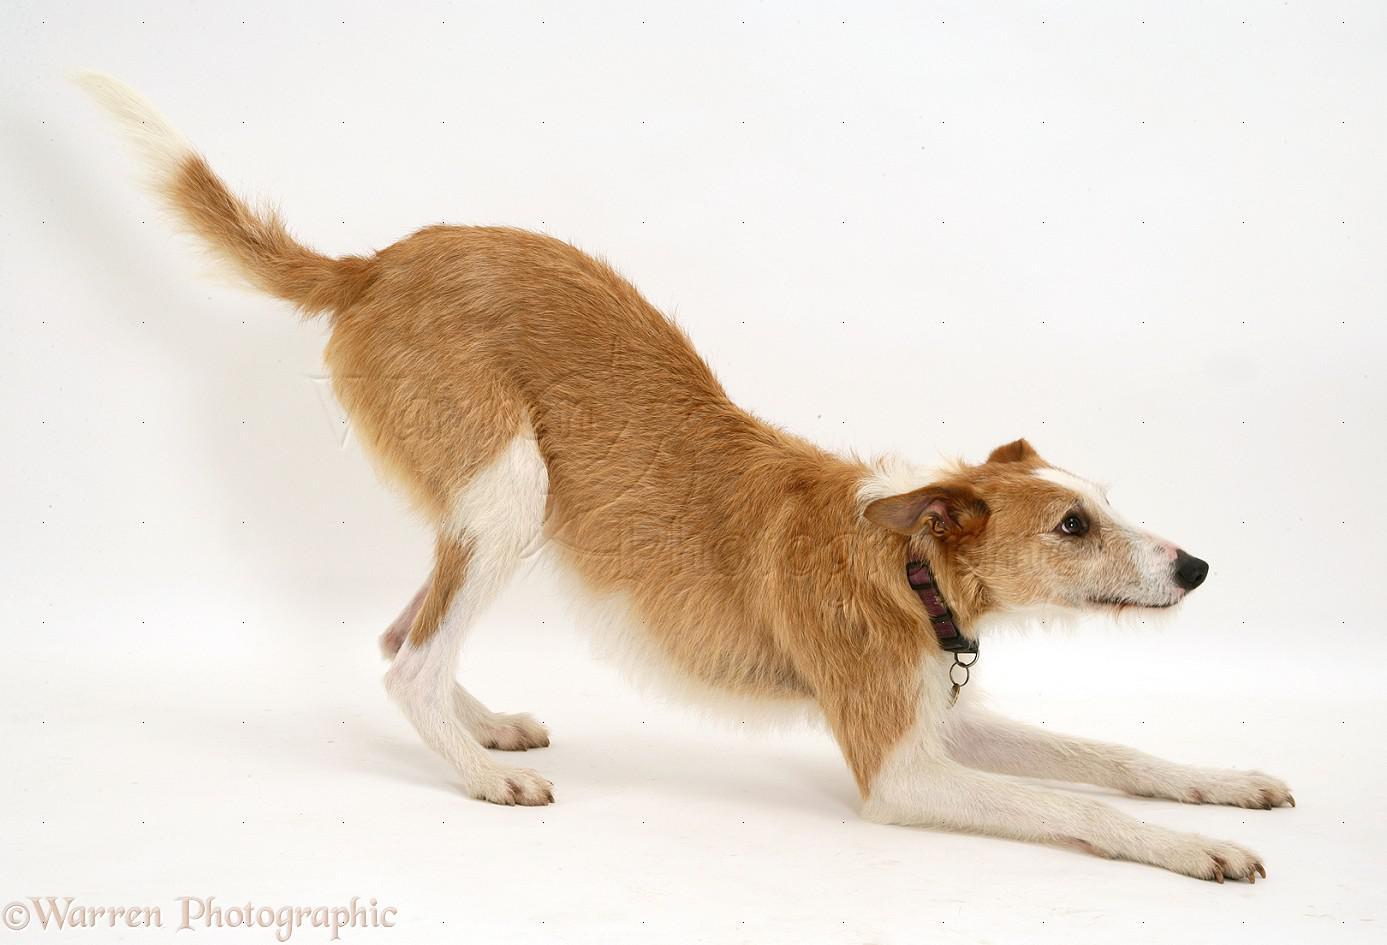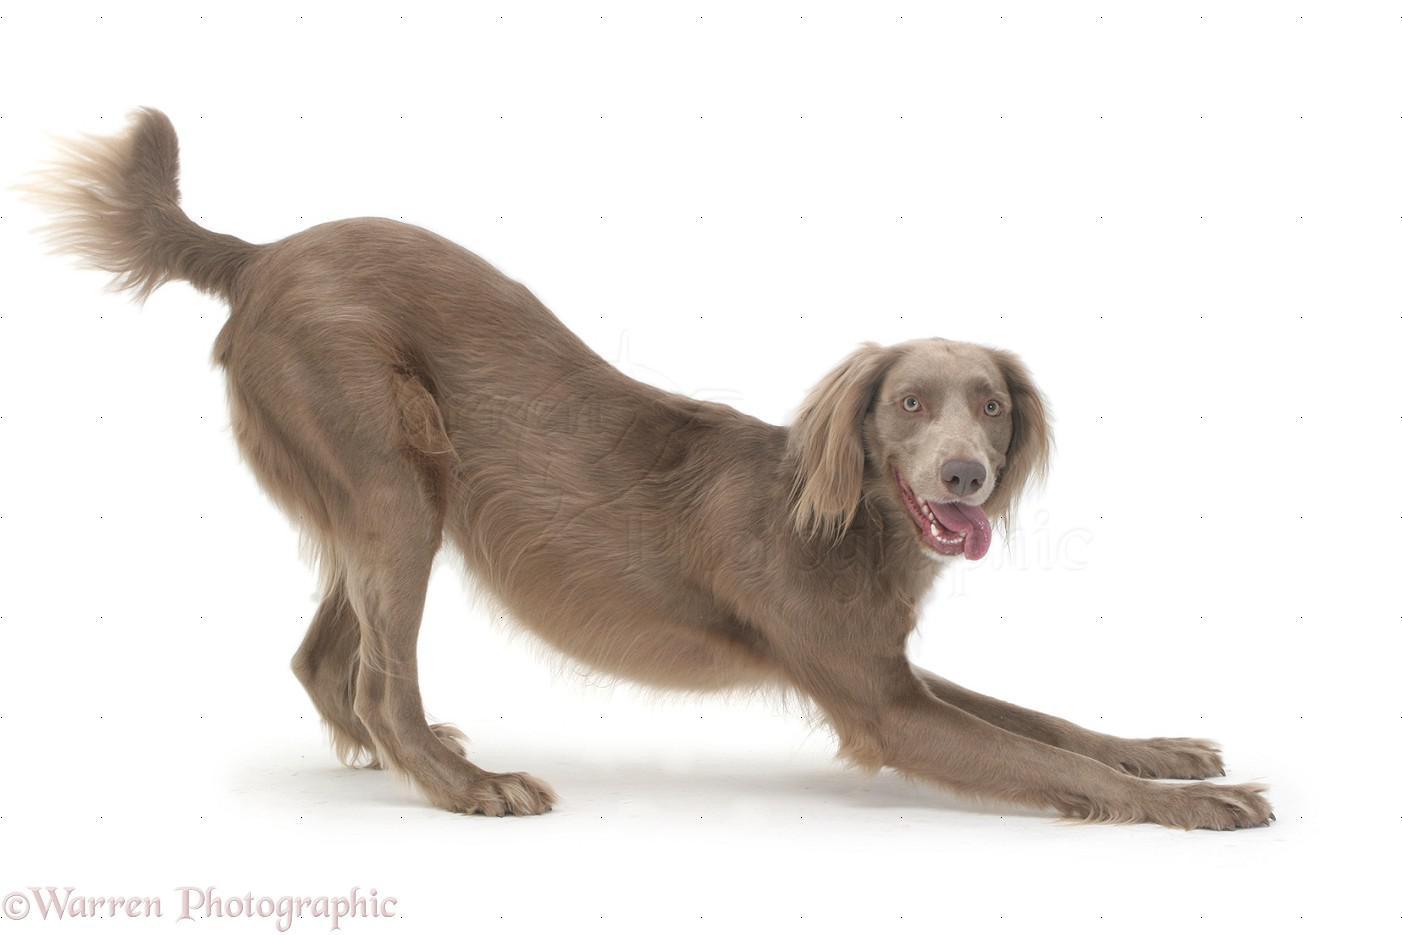The first image is the image on the left, the second image is the image on the right. Examine the images to the left and right. Is the description "Both dogs are leaning on their front legs." accurate? Answer yes or no. Yes. The first image is the image on the left, the second image is the image on the right. For the images displayed, is the sentence "Each image features a hound dog posed with its front half lowered and its hind haunches raised." factually correct? Answer yes or no. Yes. 